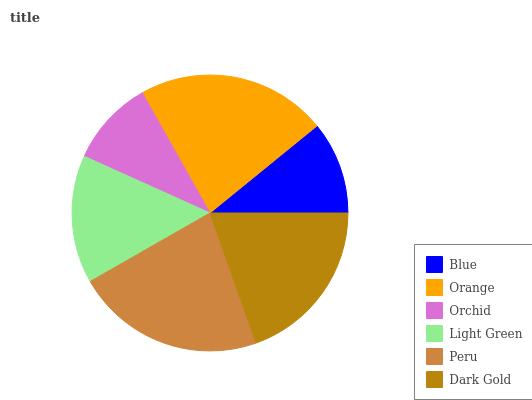Is Orchid the minimum?
Answer yes or no. Yes. Is Orange the maximum?
Answer yes or no. Yes. Is Orange the minimum?
Answer yes or no. No. Is Orchid the maximum?
Answer yes or no. No. Is Orange greater than Orchid?
Answer yes or no. Yes. Is Orchid less than Orange?
Answer yes or no. Yes. Is Orchid greater than Orange?
Answer yes or no. No. Is Orange less than Orchid?
Answer yes or no. No. Is Dark Gold the high median?
Answer yes or no. Yes. Is Light Green the low median?
Answer yes or no. Yes. Is Orchid the high median?
Answer yes or no. No. Is Orchid the low median?
Answer yes or no. No. 